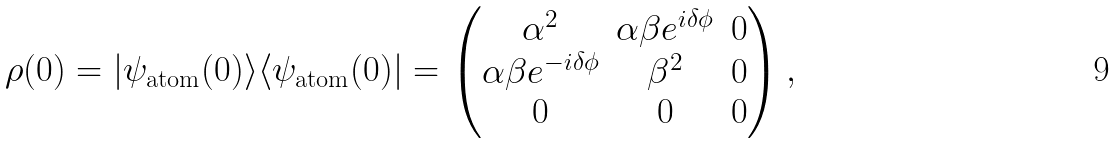Convert formula to latex. <formula><loc_0><loc_0><loc_500><loc_500>\rho ( 0 ) = | \psi _ { \text {atom} } ( 0 ) \rangle \langle \psi _ { \text {atom} } ( 0 ) | = \begin{pmatrix} \alpha ^ { 2 } & \alpha \beta e ^ { i \delta \phi } & 0 \\ \alpha \beta e ^ { - i \delta \phi } & \beta ^ { 2 } & 0 \\ 0 & 0 & 0 \end{pmatrix} ,</formula> 